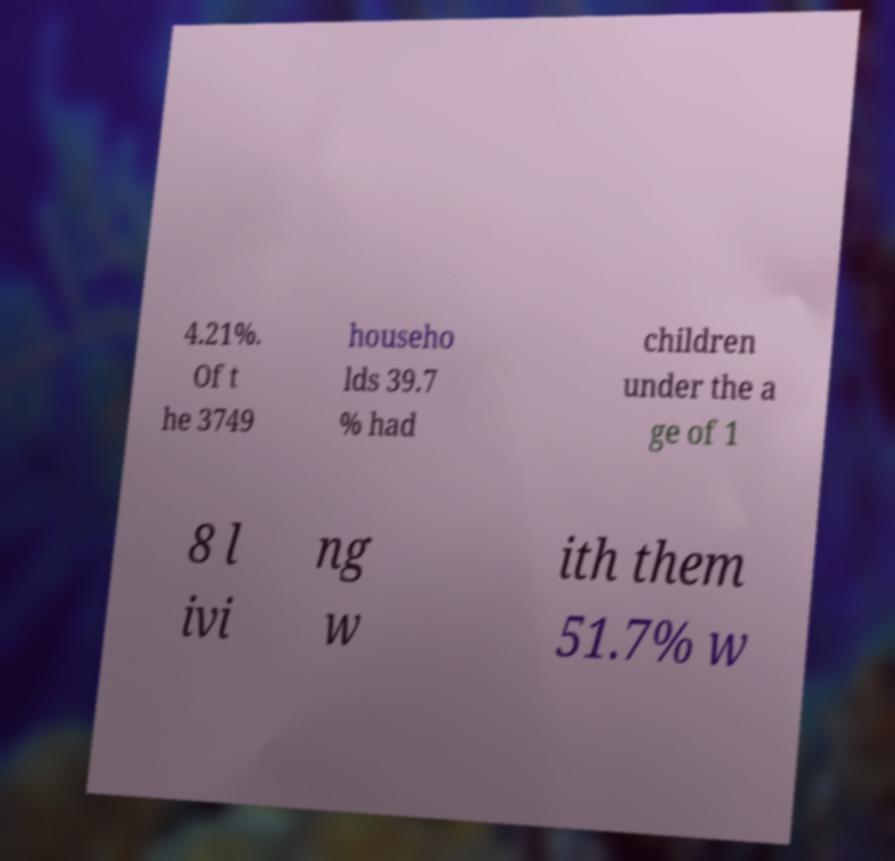Can you accurately transcribe the text from the provided image for me? 4.21%. Of t he 3749 househo lds 39.7 % had children under the a ge of 1 8 l ivi ng w ith them 51.7% w 